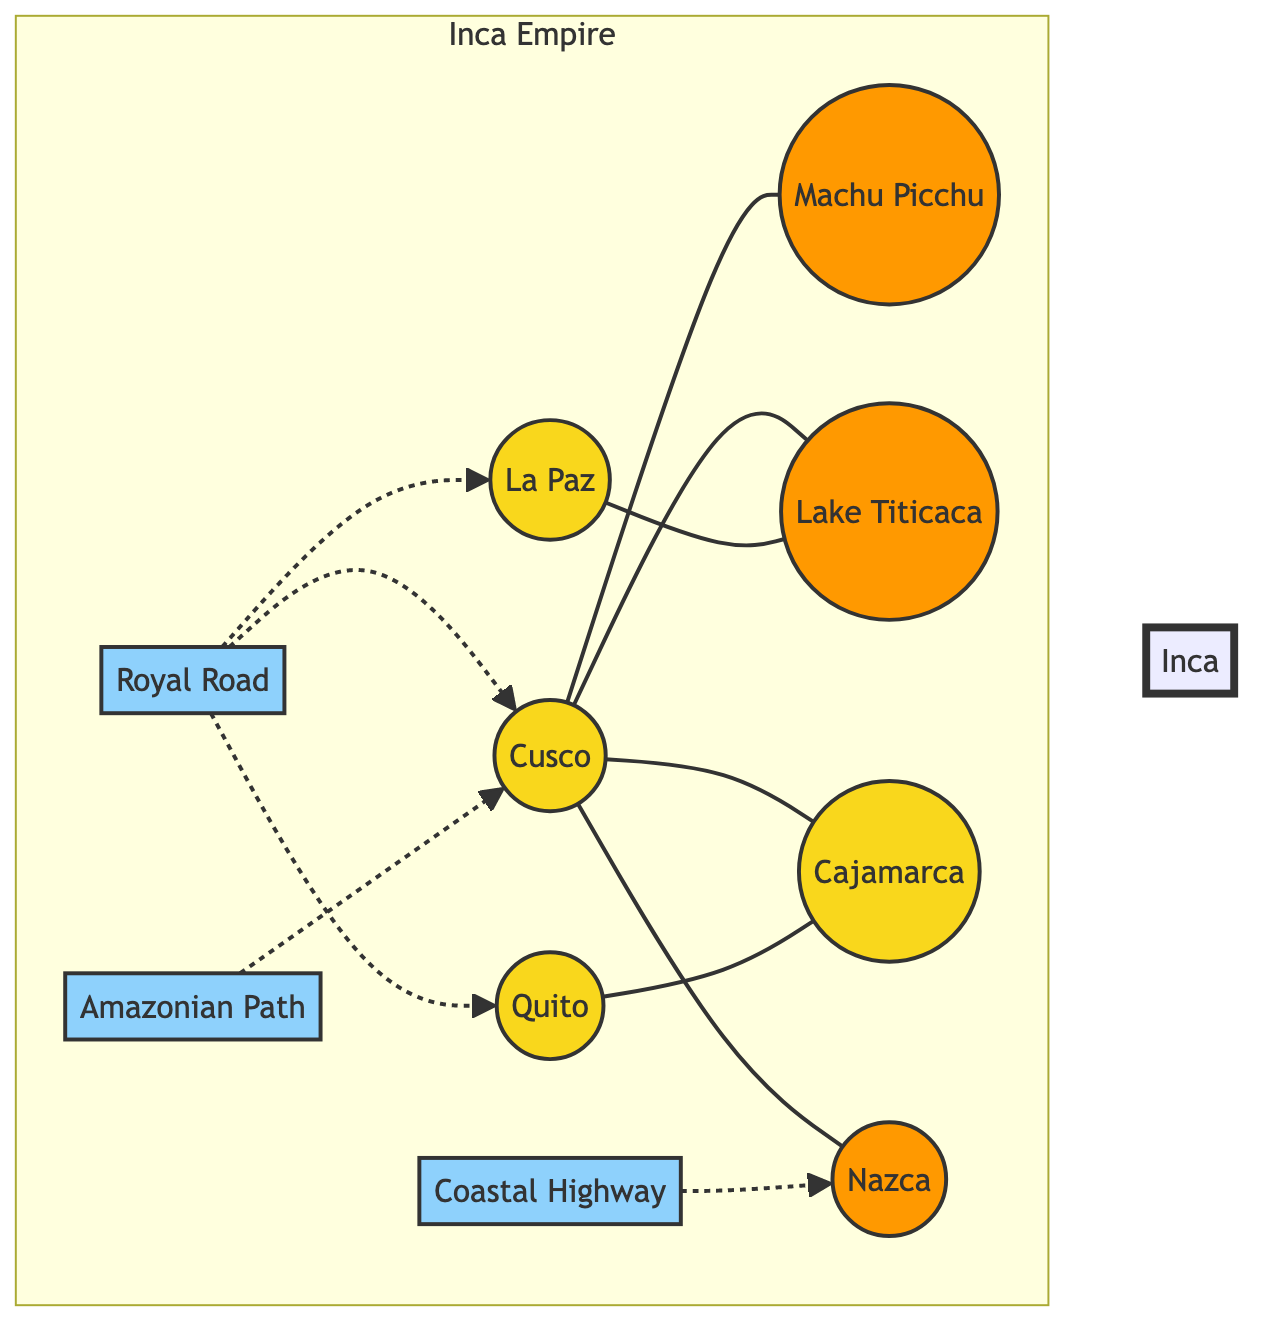What is the capital of the Inca Empire? The diagram identifies Cusco as the main location within the Inca Empire and is highlighted as the capital city.
Answer: Cusco How many major cities are shown in the diagram? The diagram shows five major cities: Cusco, Quito, La Paz, Cajamarca, and Nazca. By counting these nodes, we arrive at the collective number of cities.
Answer: 5 Which landmark is connected to Cusco? The diagram indicates connections from Cusco to three landmarks: Machu Picchu, Lake Titicaca, and Nazca. The question specifies one of these connections.
Answer: Machu Picchu What route connects Cusco to the coastal area? The Coastal Highway depicted in the diagram indicates a route leading towards the coastal city of Nazca from Cusco, showcasing the transportation path.
Answer: Coastal Highway Which city is directly connected to both Quito and La Paz? By examining the connections in the diagram, we see that Cajamarca is connected to both Quito (to the northwest) and La Paz (to the southeast).
Answer: Cajamarca How many trade routes are represented in the diagram? The diagram illustrates three defined routes: the Royal Road, Coastal Highway, and Amazonian Path. Counting these nodes gives us the total number of routes.
Answer: 3 What is the relationship between Cusco and Lake Titicaca? The diagram shows a direct connection (a solid line) between Cusco and Lake Titicaca, indicating a transport link between these two locations.
Answer: Connected Which transport path has a dotted line leading towards Cusco? The Amazonian Path is shown with a dotted line leading towards Cusco, indicating it serves as a path of lesser formal or differing travel styles compared to solid routes.
Answer: Amazonian Path What geographical feature is represented by Lake Titicaca? The diagram displays Lake Titicaca as a landmark, suggesting it is a significant geographical body present in the Inca Empire.
Answer: Landmark 